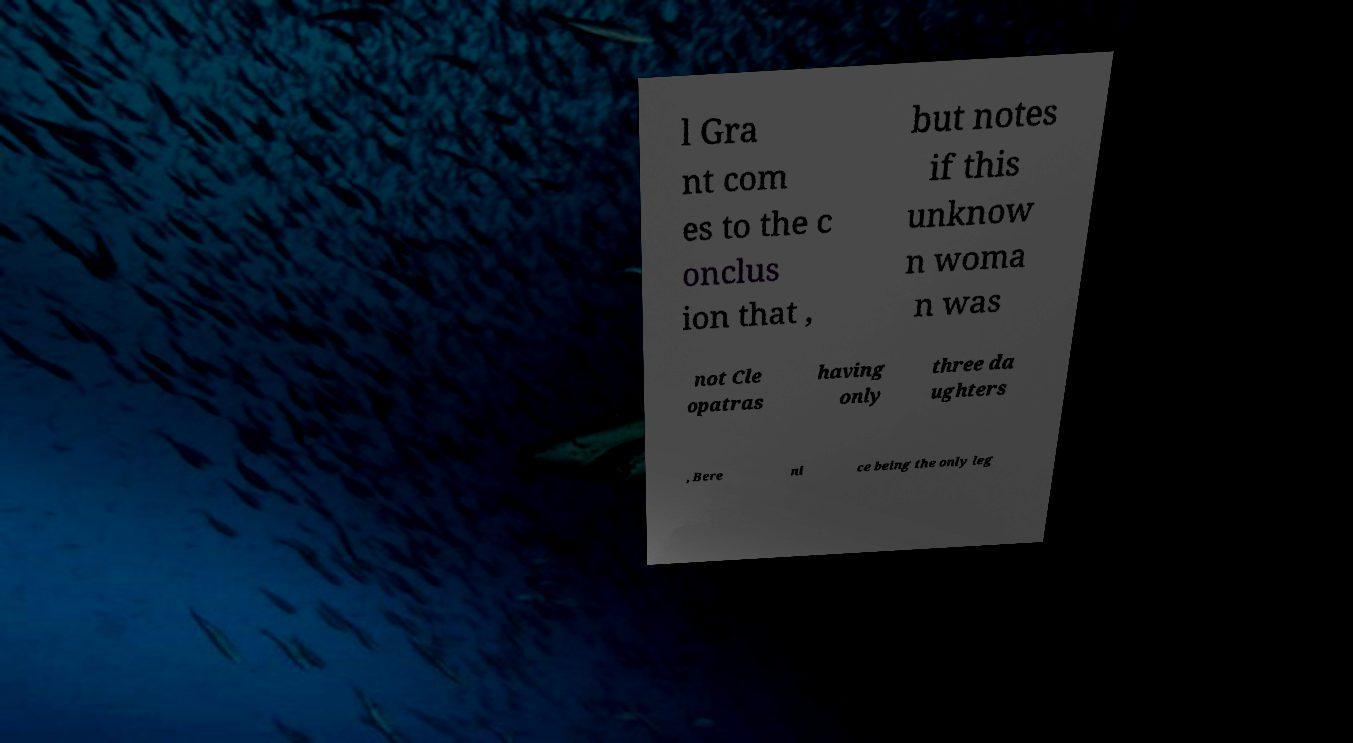Can you read and provide the text displayed in the image?This photo seems to have some interesting text. Can you extract and type it out for me? l Gra nt com es to the c onclus ion that , but notes if this unknow n woma n was not Cle opatras having only three da ughters , Bere ni ce being the only leg 